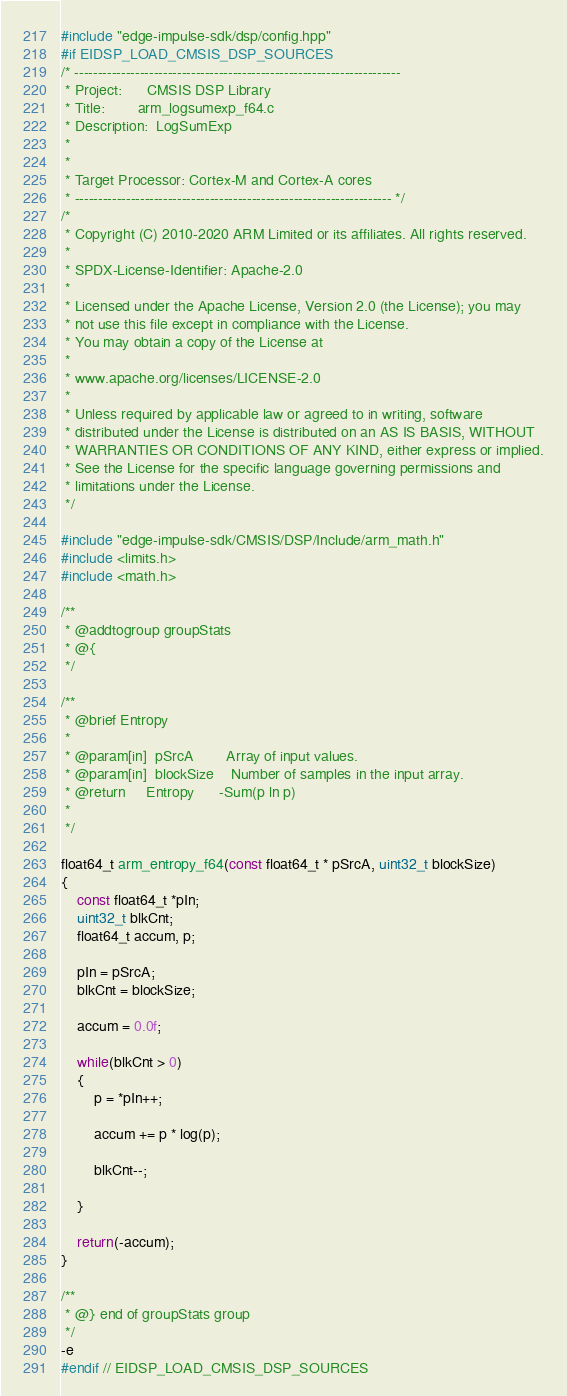Convert code to text. <code><loc_0><loc_0><loc_500><loc_500><_C_>#include "edge-impulse-sdk/dsp/config.hpp"
#if EIDSP_LOAD_CMSIS_DSP_SOURCES
/* ----------------------------------------------------------------------
 * Project:      CMSIS DSP Library
 * Title:        arm_logsumexp_f64.c
 * Description:  LogSumExp
 *
 *
 * Target Processor: Cortex-M and Cortex-A cores
 * -------------------------------------------------------------------- */
/*
 * Copyright (C) 2010-2020 ARM Limited or its affiliates. All rights reserved.
 *
 * SPDX-License-Identifier: Apache-2.0
 *
 * Licensed under the Apache License, Version 2.0 (the License); you may
 * not use this file except in compliance with the License.
 * You may obtain a copy of the License at
 *
 * www.apache.org/licenses/LICENSE-2.0
 *
 * Unless required by applicable law or agreed to in writing, software
 * distributed under the License is distributed on an AS IS BASIS, WITHOUT
 * WARRANTIES OR CONDITIONS OF ANY KIND, either express or implied.
 * See the License for the specific language governing permissions and
 * limitations under the License.
 */

#include "edge-impulse-sdk/CMSIS/DSP/Include/arm_math.h"
#include <limits.h>
#include <math.h>

/**
 * @addtogroup groupStats
 * @{
 */

/**
 * @brief Entropy
 *
 * @param[in]  pSrcA        Array of input values.
 * @param[in]  blockSize    Number of samples in the input array.
 * @return     Entropy      -Sum(p ln p)
 *
 */

float64_t arm_entropy_f64(const float64_t * pSrcA, uint32_t blockSize)
{
    const float64_t *pIn;
    uint32_t blkCnt;
    float64_t accum, p;
 
    pIn = pSrcA;
    blkCnt = blockSize;

    accum = 0.0f;

    while(blkCnt > 0)
    {
        p = *pIn++;

        accum += p * log(p);
       
        blkCnt--;
    
    }

    return(-accum);
}

/**
 * @} end of groupStats group
 */
-e 
#endif // EIDSP_LOAD_CMSIS_DSP_SOURCES
</code> 